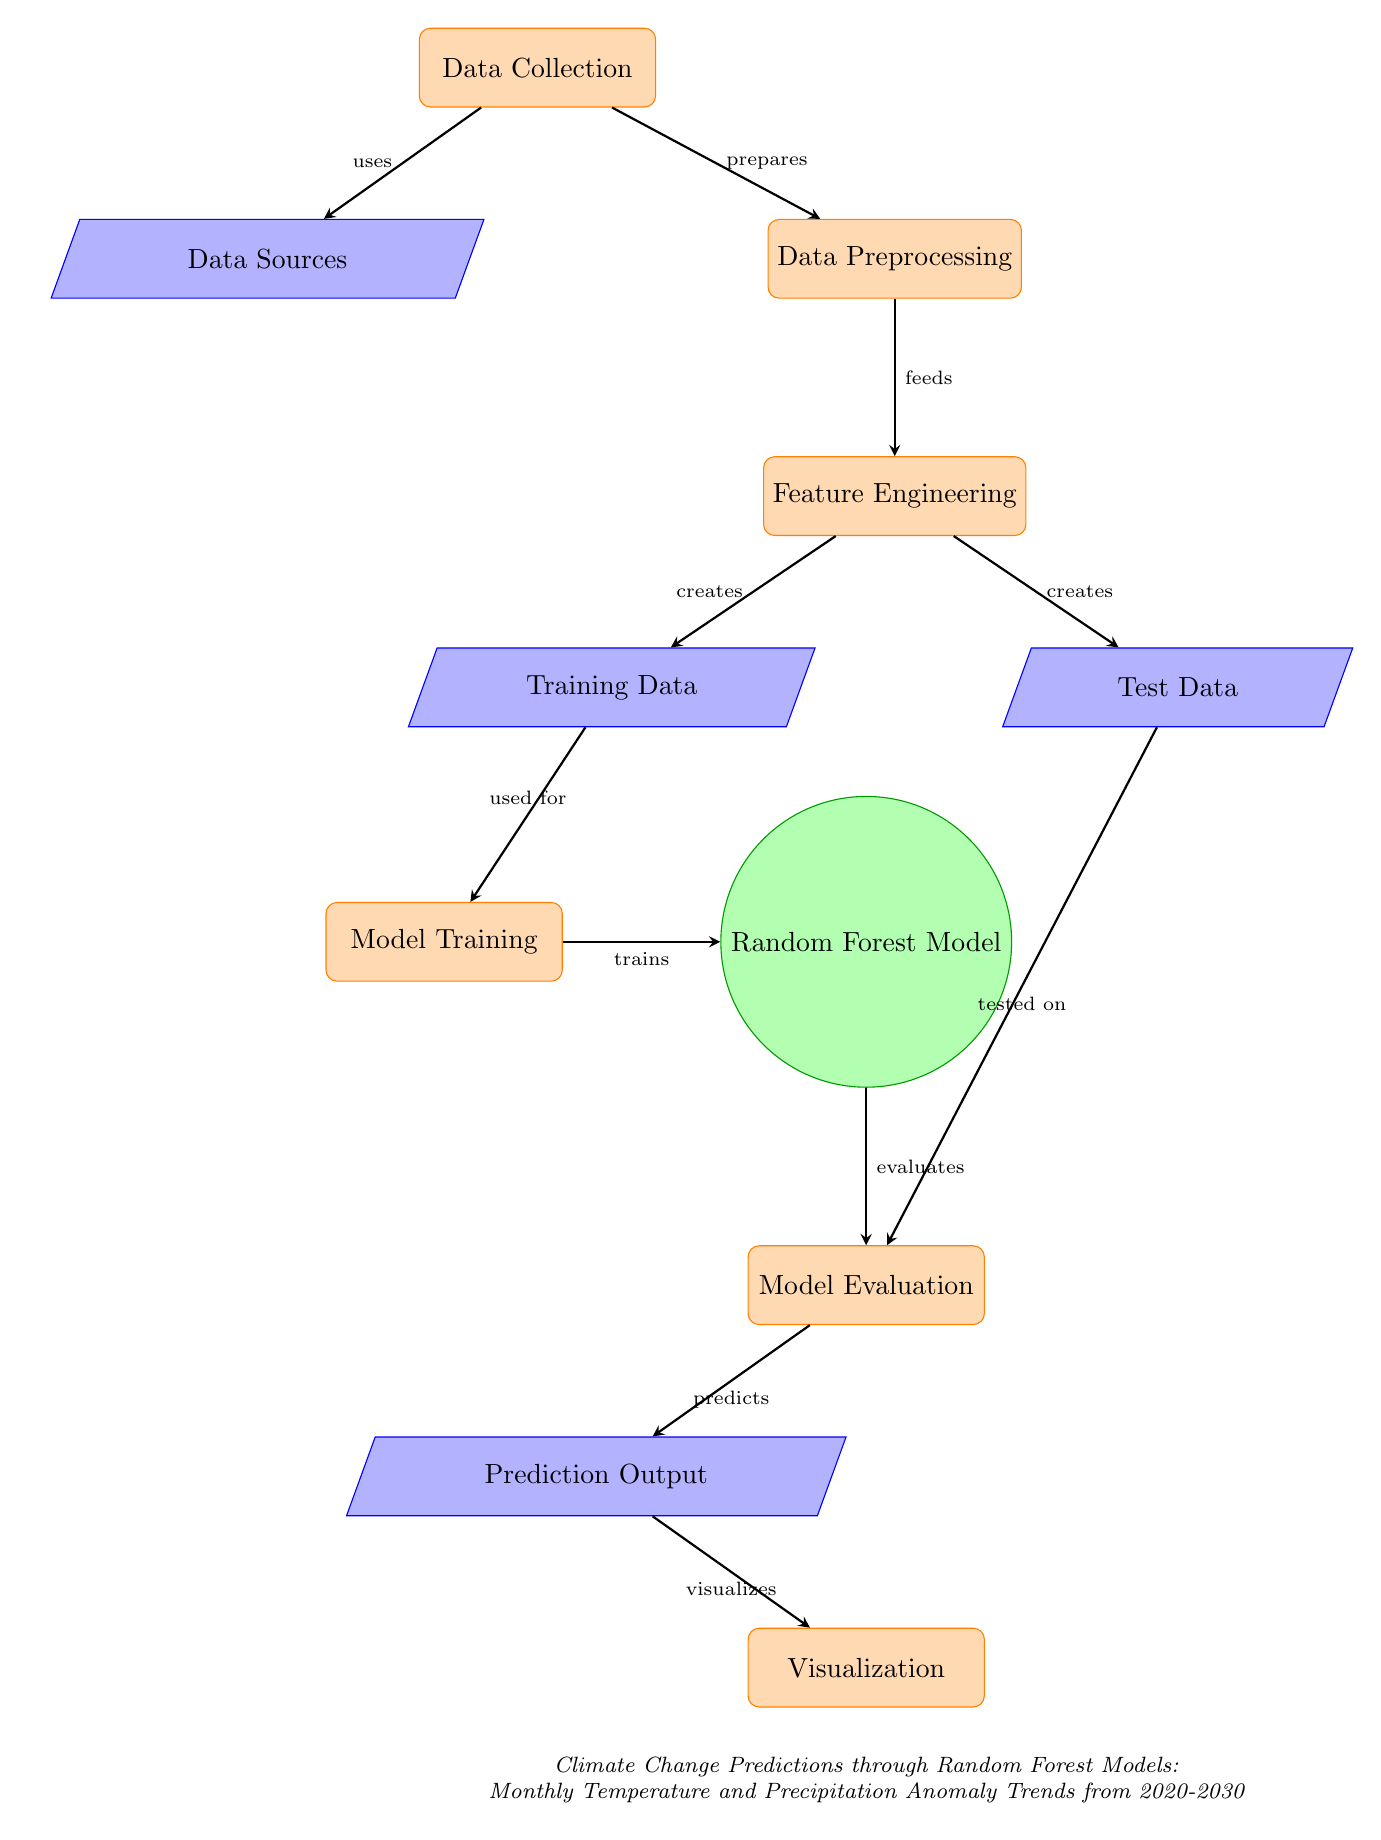What is the starting point of the diagram? The diagram starts with the "Data Collection" process node, which is positioned at the top of the diagram. This is the first step in the workflow before moving to data sources or preprocessing.
Answer: Data Collection How many data sources are mentioned? There is one "Data Sources" node depicted in the diagram, specifically positioned below the "Data Collection" process node. This node represents the various origins of data used in the model.
Answer: One What is the output of the model evaluation process? The output from the "Model Evaluation" process is directed towards the "Prediction Output" data node, indicating the results of the model's evaluation phase.
Answer: Prediction Output Which node creates the training and test data? The "Feature Engineering" process node is responsible for creating both the "Training Data" and "Test Data" nodes as indicated by the arrows feeding into each of them.
Answer: Feature Engineering What process precedes the model training? The "Training Data" node is the input that precedes the "Model Training" process, as it feeds directly into the training of the Random Forest Model.
Answer: Training Data How does the Random Forest Model interact with model evaluation? The Random Forest Model is evaluated by the "Model Evaluation" process, indicating that the outputs of the model are assessed at this stage before making predictions.
Answer: Evaluates What are the two outcomes of the model after evaluation? The two outcomes after the "Model Evaluation" are "Prediction Output" and "Visualization," indicating the model's predictions and their visual representation.
Answer: Prediction Output and Visualization Which node is positioned directly below the Random Forest Model? The "Model Evaluation" process node is positioned directly below the Random Forest Model in the flow chart, indicating it is the next step following model training.
Answer: Model Evaluation How many processes are present in the diagram? There are six process nodes present in the diagram: "Data Collection", "Data Preprocessing", "Feature Engineering", "Model Training", "Model Evaluation", and "Visualization."
Answer: Six What is the significance of the arrow marked "tested on"? The arrow labeled "tested on" indicates the relationship between "Test Data" and "Model Evaluation," suggesting that the model's effectiveness is assessed using the test data.
Answer: Assesses model effectiveness 